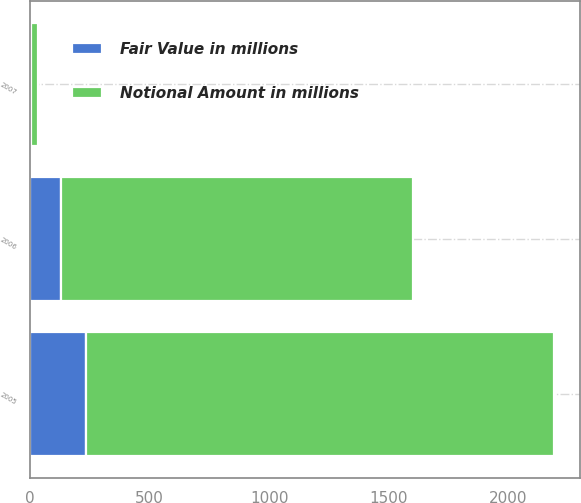Convert chart. <chart><loc_0><loc_0><loc_500><loc_500><stacked_bar_chart><ecel><fcel>2005<fcel>2006<fcel>2007<nl><fcel>Notional Amount in millions<fcel>1958<fcel>1473<fcel>30<nl><fcel>Fair Value in millions<fcel>232<fcel>128<fcel>2<nl></chart> 